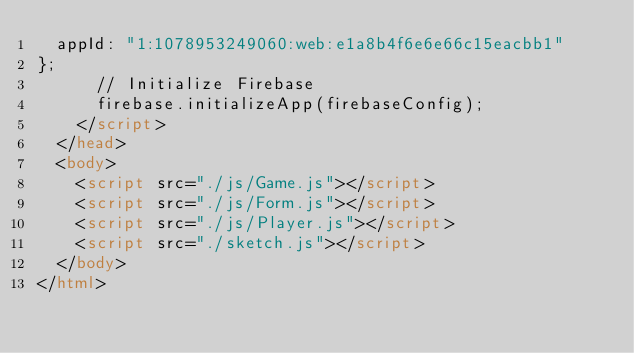Convert code to text. <code><loc_0><loc_0><loc_500><loc_500><_HTML_>  appId: "1:1078953249060:web:e1a8b4f6e6e66c15eacbb1"
};
      // Initialize Firebase
      firebase.initializeApp(firebaseConfig);
    </script>
  </head>
  <body>
    <script src="./js/Game.js"></script>
    <script src="./js/Form.js"></script>
    <script src="./js/Player.js"></script>
    <script src="./sketch.js"></script>
  </body>
</html>
</code> 